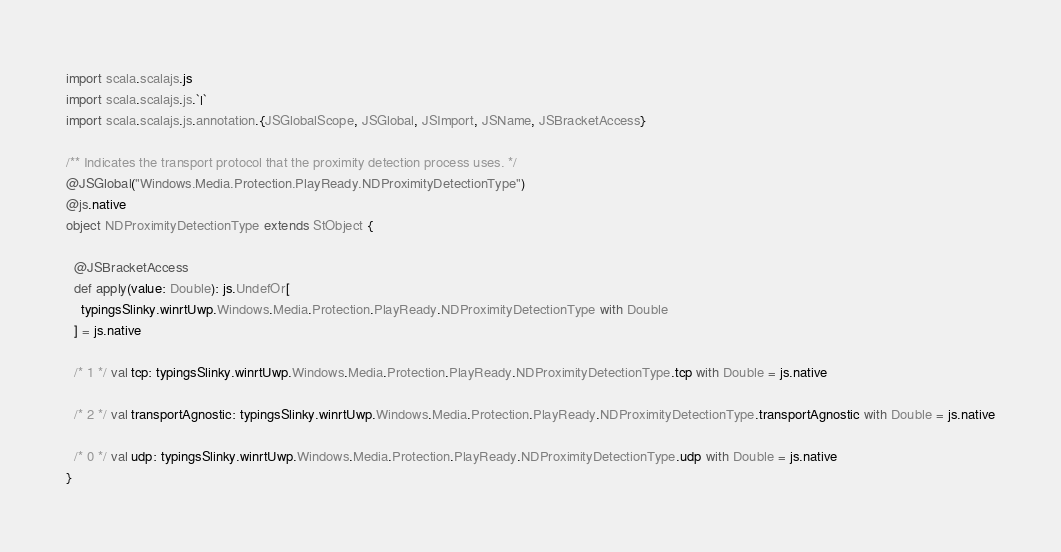Convert code to text. <code><loc_0><loc_0><loc_500><loc_500><_Scala_>import scala.scalajs.js
import scala.scalajs.js.`|`
import scala.scalajs.js.annotation.{JSGlobalScope, JSGlobal, JSImport, JSName, JSBracketAccess}

/** Indicates the transport protocol that the proximity detection process uses. */
@JSGlobal("Windows.Media.Protection.PlayReady.NDProximityDetectionType")
@js.native
object NDProximityDetectionType extends StObject {
  
  @JSBracketAccess
  def apply(value: Double): js.UndefOr[
    typingsSlinky.winrtUwp.Windows.Media.Protection.PlayReady.NDProximityDetectionType with Double
  ] = js.native
  
  /* 1 */ val tcp: typingsSlinky.winrtUwp.Windows.Media.Protection.PlayReady.NDProximityDetectionType.tcp with Double = js.native
  
  /* 2 */ val transportAgnostic: typingsSlinky.winrtUwp.Windows.Media.Protection.PlayReady.NDProximityDetectionType.transportAgnostic with Double = js.native
  
  /* 0 */ val udp: typingsSlinky.winrtUwp.Windows.Media.Protection.PlayReady.NDProximityDetectionType.udp with Double = js.native
}
</code> 